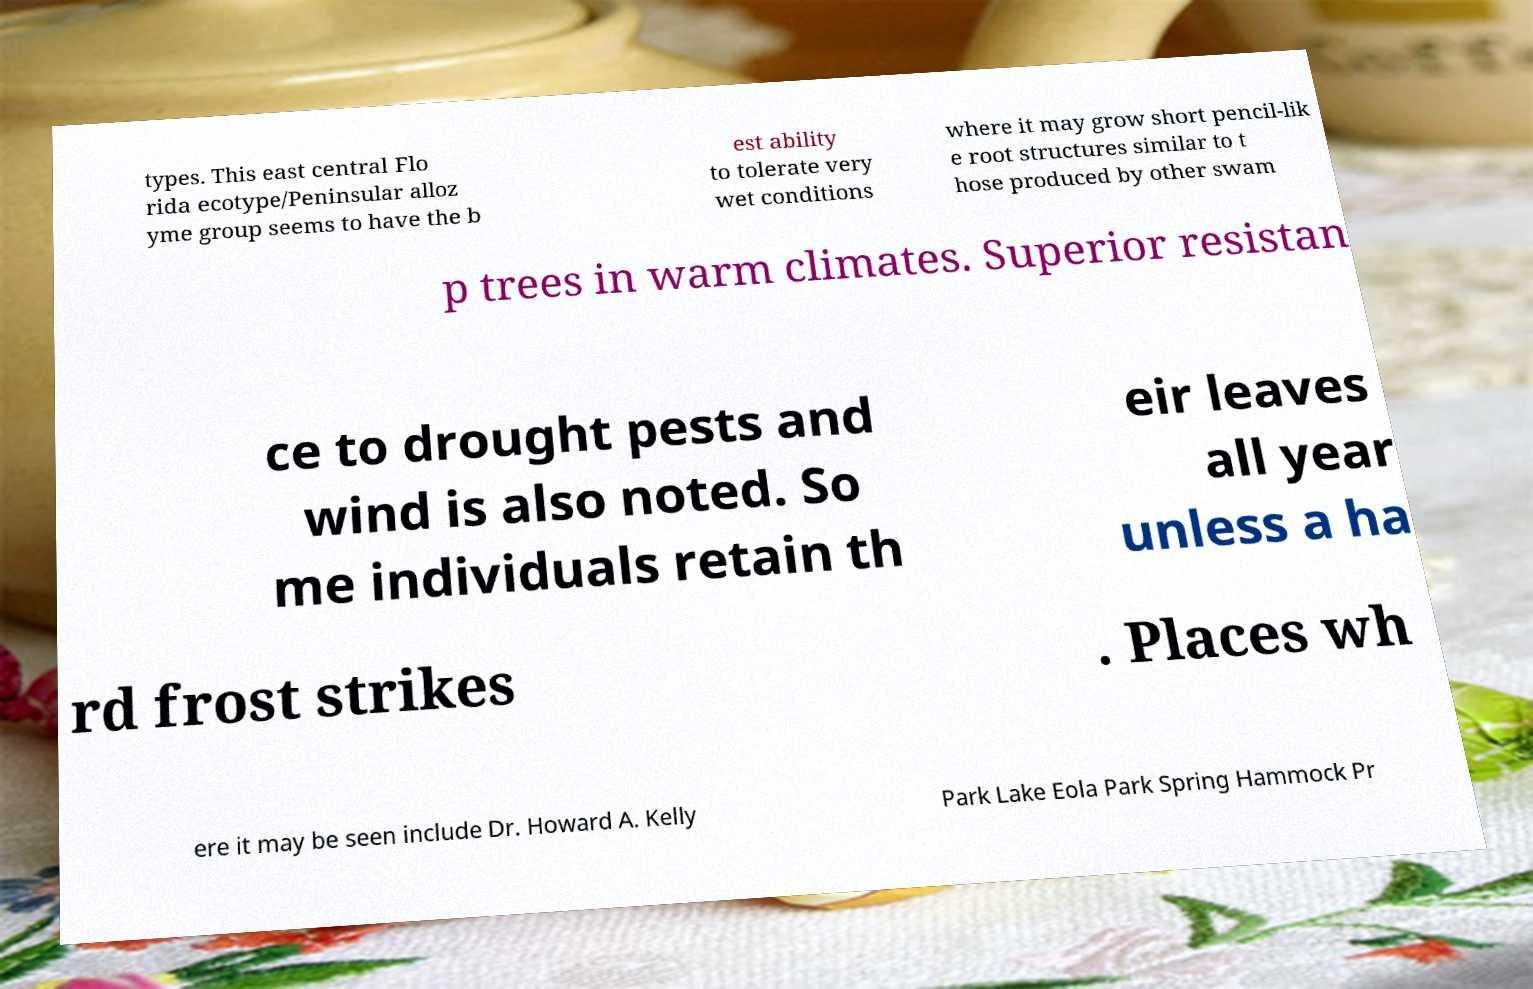There's text embedded in this image that I need extracted. Can you transcribe it verbatim? types. This east central Flo rida ecotype/Peninsular alloz yme group seems to have the b est ability to tolerate very wet conditions where it may grow short pencil-lik e root structures similar to t hose produced by other swam p trees in warm climates. Superior resistan ce to drought pests and wind is also noted. So me individuals retain th eir leaves all year unless a ha rd frost strikes . Places wh ere it may be seen include Dr. Howard A. Kelly Park Lake Eola Park Spring Hammock Pr 